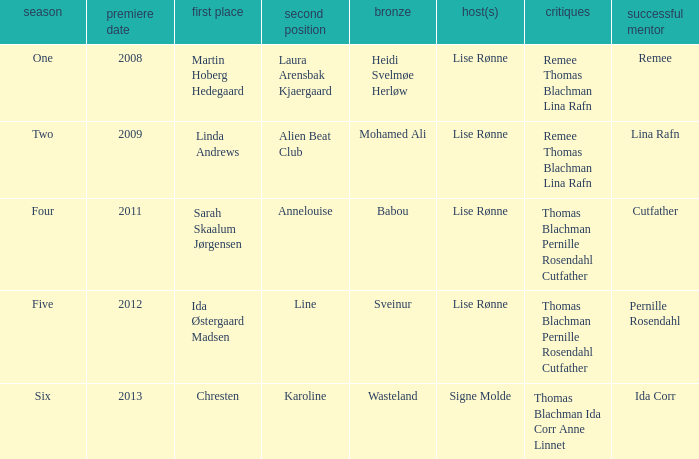Who won third place in season four? Babou. 